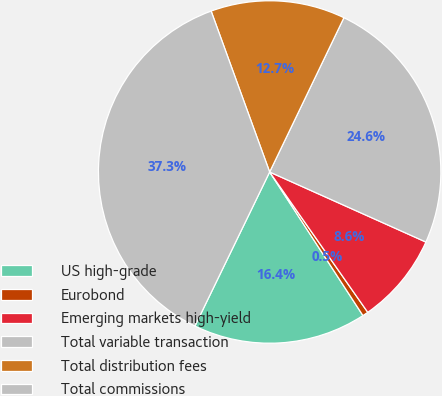Convert chart to OTSL. <chart><loc_0><loc_0><loc_500><loc_500><pie_chart><fcel>US high-grade<fcel>Eurobond<fcel>Emerging markets high-yield<fcel>Total variable transaction<fcel>Total distribution fees<fcel>Total commissions<nl><fcel>16.36%<fcel>0.54%<fcel>8.58%<fcel>24.57%<fcel>12.69%<fcel>37.26%<nl></chart> 